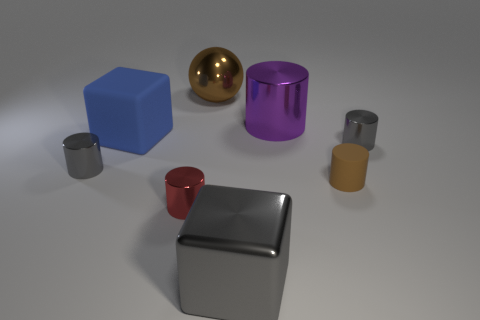What color is the large cylinder that is made of the same material as the sphere?
Provide a short and direct response. Purple. There is a big blue thing; is its shape the same as the big object in front of the small brown rubber object?
Provide a succinct answer. Yes. What is the material of the cylinder that is the same color as the large sphere?
Ensure brevity in your answer.  Rubber. What is the material of the brown cylinder that is the same size as the red thing?
Your response must be concise. Rubber. Is there a large shiny cylinder of the same color as the sphere?
Make the answer very short. No. There is a metal thing that is both to the right of the blue matte thing and on the left side of the large metallic ball; what shape is it?
Make the answer very short. Cylinder. What number of tiny gray cylinders have the same material as the red cylinder?
Your response must be concise. 2. Are there fewer tiny gray metal cylinders that are right of the big blue cube than brown shiny objects that are in front of the tiny brown object?
Make the answer very short. No. What material is the tiny gray cylinder that is right of the tiny gray metal thing to the left of the rubber object that is on the right side of the brown ball made of?
Your answer should be very brief. Metal. There is a gray object that is behind the tiny matte object and left of the big purple cylinder; what is its size?
Provide a succinct answer. Small. 